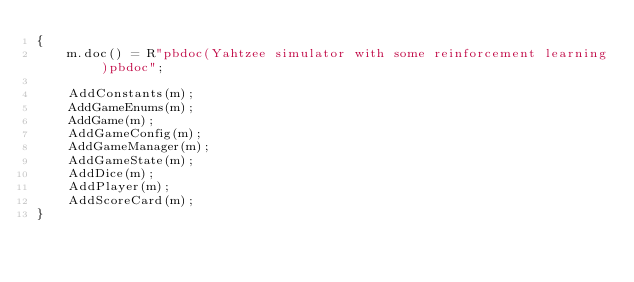Convert code to text. <code><loc_0><loc_0><loc_500><loc_500><_C++_>{
    m.doc() = R"pbdoc(Yahtzee simulator with some reinforcement learning)pbdoc";

    AddConstants(m);
    AddGameEnums(m);
    AddGame(m);
    AddGameConfig(m);
    AddGameManager(m);
    AddGameState(m);
    AddDice(m);
    AddPlayer(m);
    AddScoreCard(m);
}</code> 